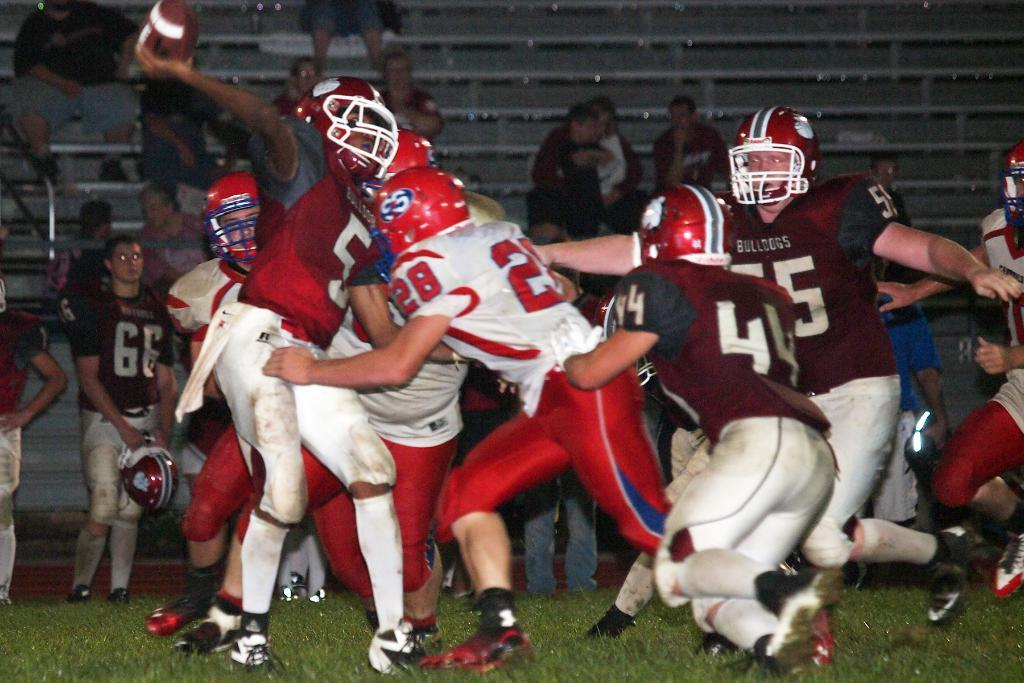What time of day was the image taken? The image was taken during night time. What activity is being performed by the people in the foreground of the image? The people in the foreground of the image are playing rugby in a grass court. What can be seen in the background of the image? There are benches and an audience in the background of the image. Are there any other people visible in the image besides the rugby players? Yes, there are people in the background of the image. What type of potato is being discussed by the audience in the image? There is no mention of a potato or any discussion about it in the image. 